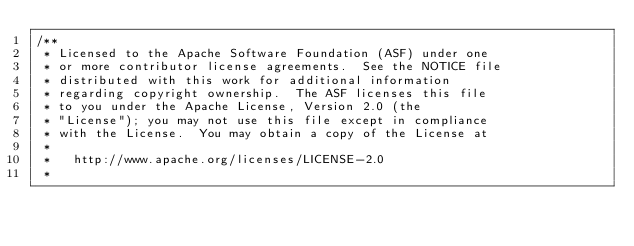Convert code to text. <code><loc_0><loc_0><loc_500><loc_500><_C++_>/**
 * Licensed to the Apache Software Foundation (ASF) under one
 * or more contributor license agreements.  See the NOTICE file
 * distributed with this work for additional information
 * regarding copyright ownership.  The ASF licenses this file
 * to you under the Apache License, Version 2.0 (the
 * "License"); you may not use this file except in compliance
 * with the License.  You may obtain a copy of the License at
 *
 *   http://www.apache.org/licenses/LICENSE-2.0
 *</code> 